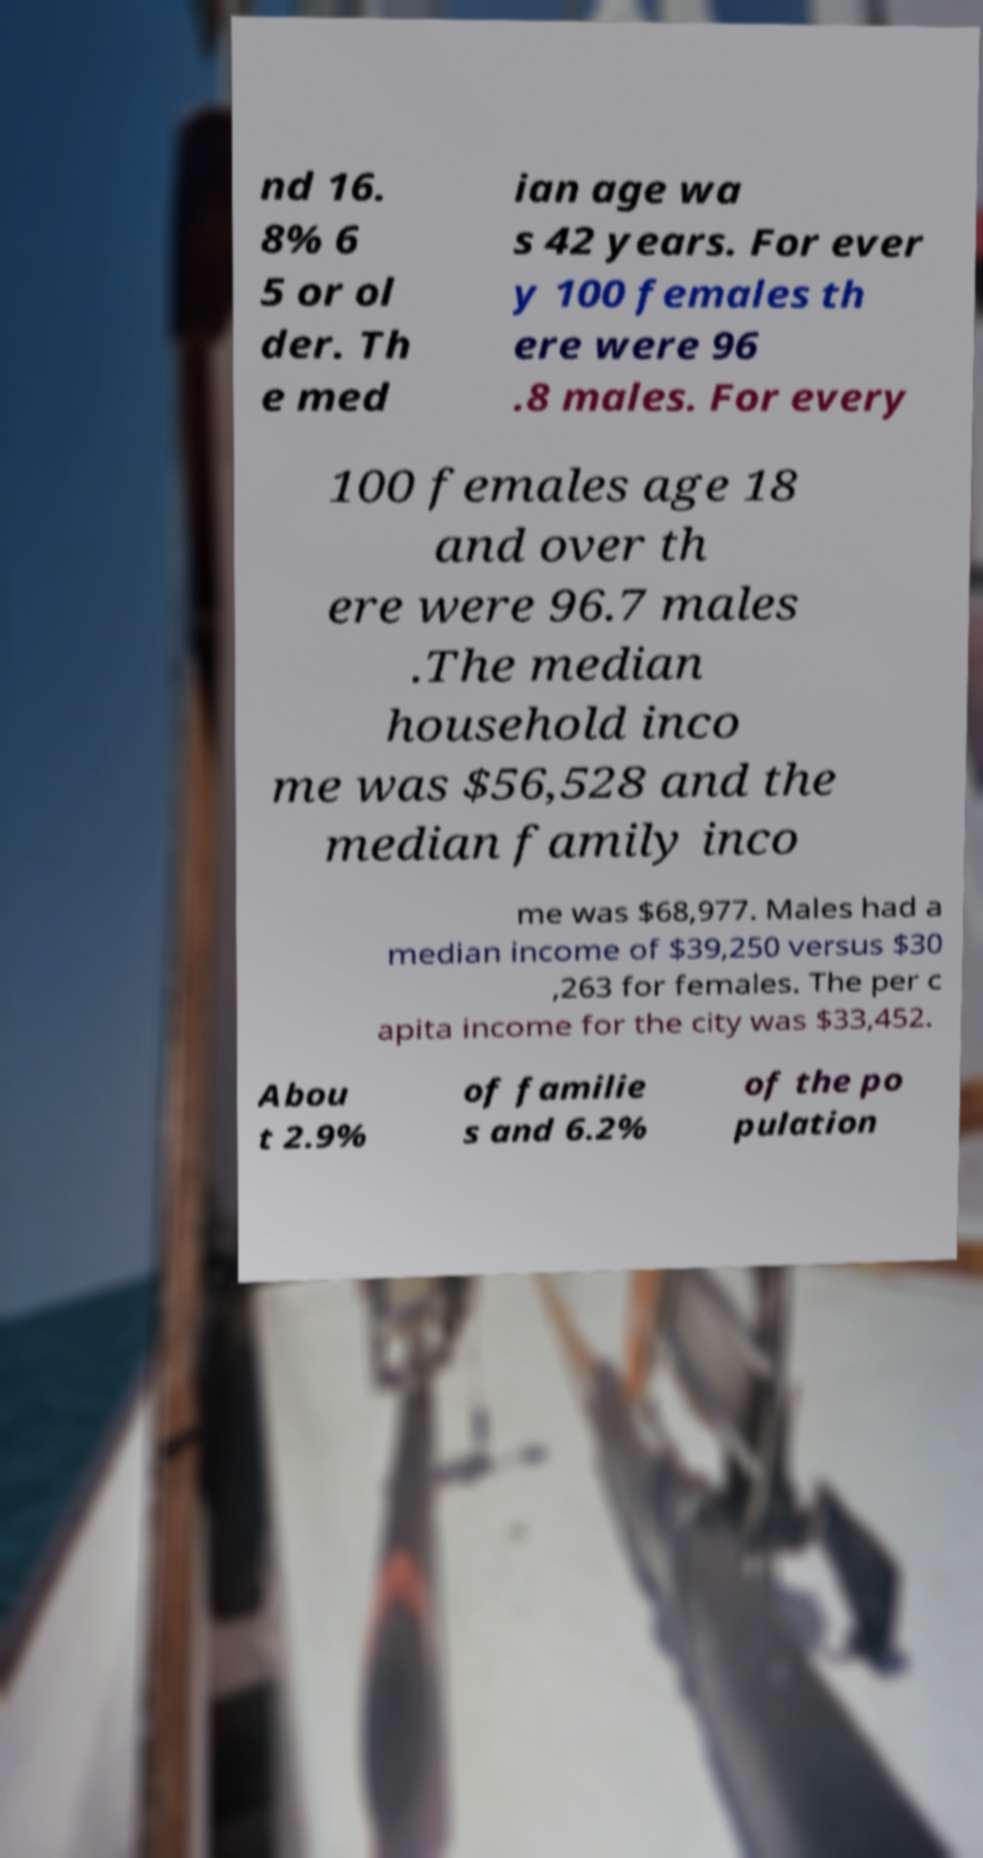For documentation purposes, I need the text within this image transcribed. Could you provide that? nd 16. 8% 6 5 or ol der. Th e med ian age wa s 42 years. For ever y 100 females th ere were 96 .8 males. For every 100 females age 18 and over th ere were 96.7 males .The median household inco me was $56,528 and the median family inco me was $68,977. Males had a median income of $39,250 versus $30 ,263 for females. The per c apita income for the city was $33,452. Abou t 2.9% of familie s and 6.2% of the po pulation 